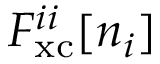Convert formula to latex. <formula><loc_0><loc_0><loc_500><loc_500>F _ { x c } ^ { i i } [ n _ { i } ]</formula> 